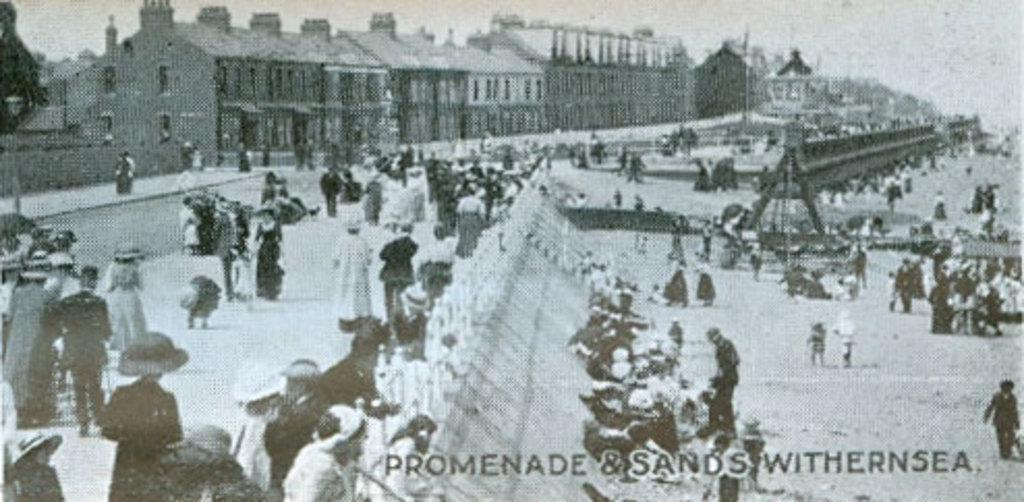What is the color scheme of the image? The image is black and white. What can be seen in the middle of the image? There are persons in the middle of the image. What type of dress is the person wearing in the image? There is no dress visible in the image, as it is in black and white and does not show any clothing details. 